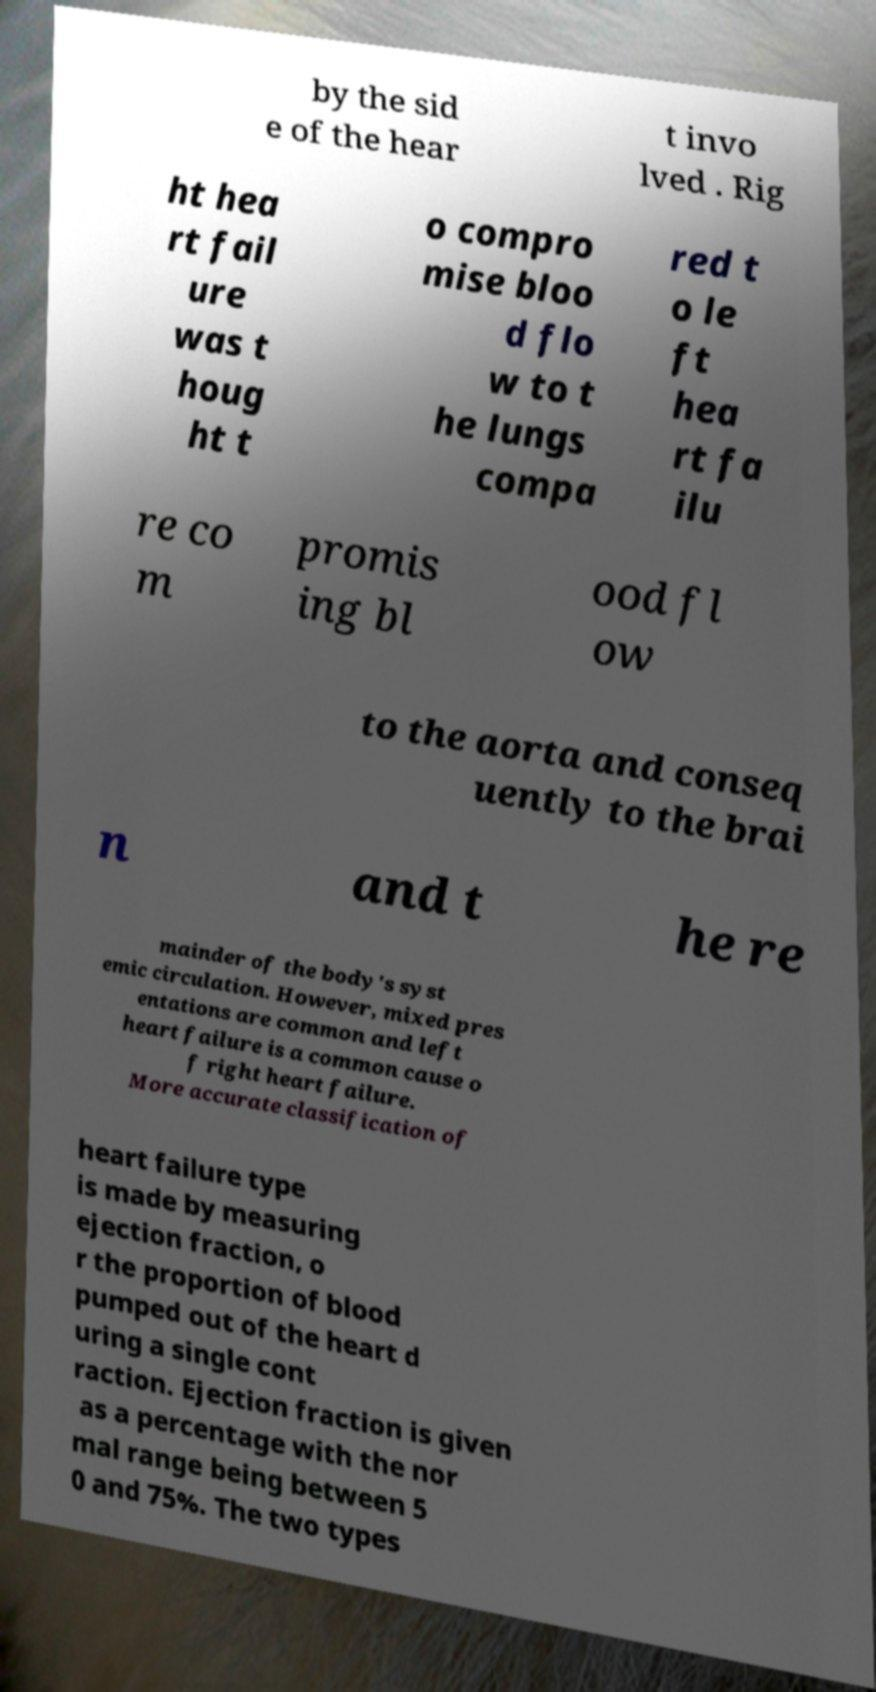I need the written content from this picture converted into text. Can you do that? by the sid e of the hear t invo lved . Rig ht hea rt fail ure was t houg ht t o compro mise bloo d flo w to t he lungs compa red t o le ft hea rt fa ilu re co m promis ing bl ood fl ow to the aorta and conseq uently to the brai n and t he re mainder of the body's syst emic circulation. However, mixed pres entations are common and left heart failure is a common cause o f right heart failure. More accurate classification of heart failure type is made by measuring ejection fraction, o r the proportion of blood pumped out of the heart d uring a single cont raction. Ejection fraction is given as a percentage with the nor mal range being between 5 0 and 75%. The two types 